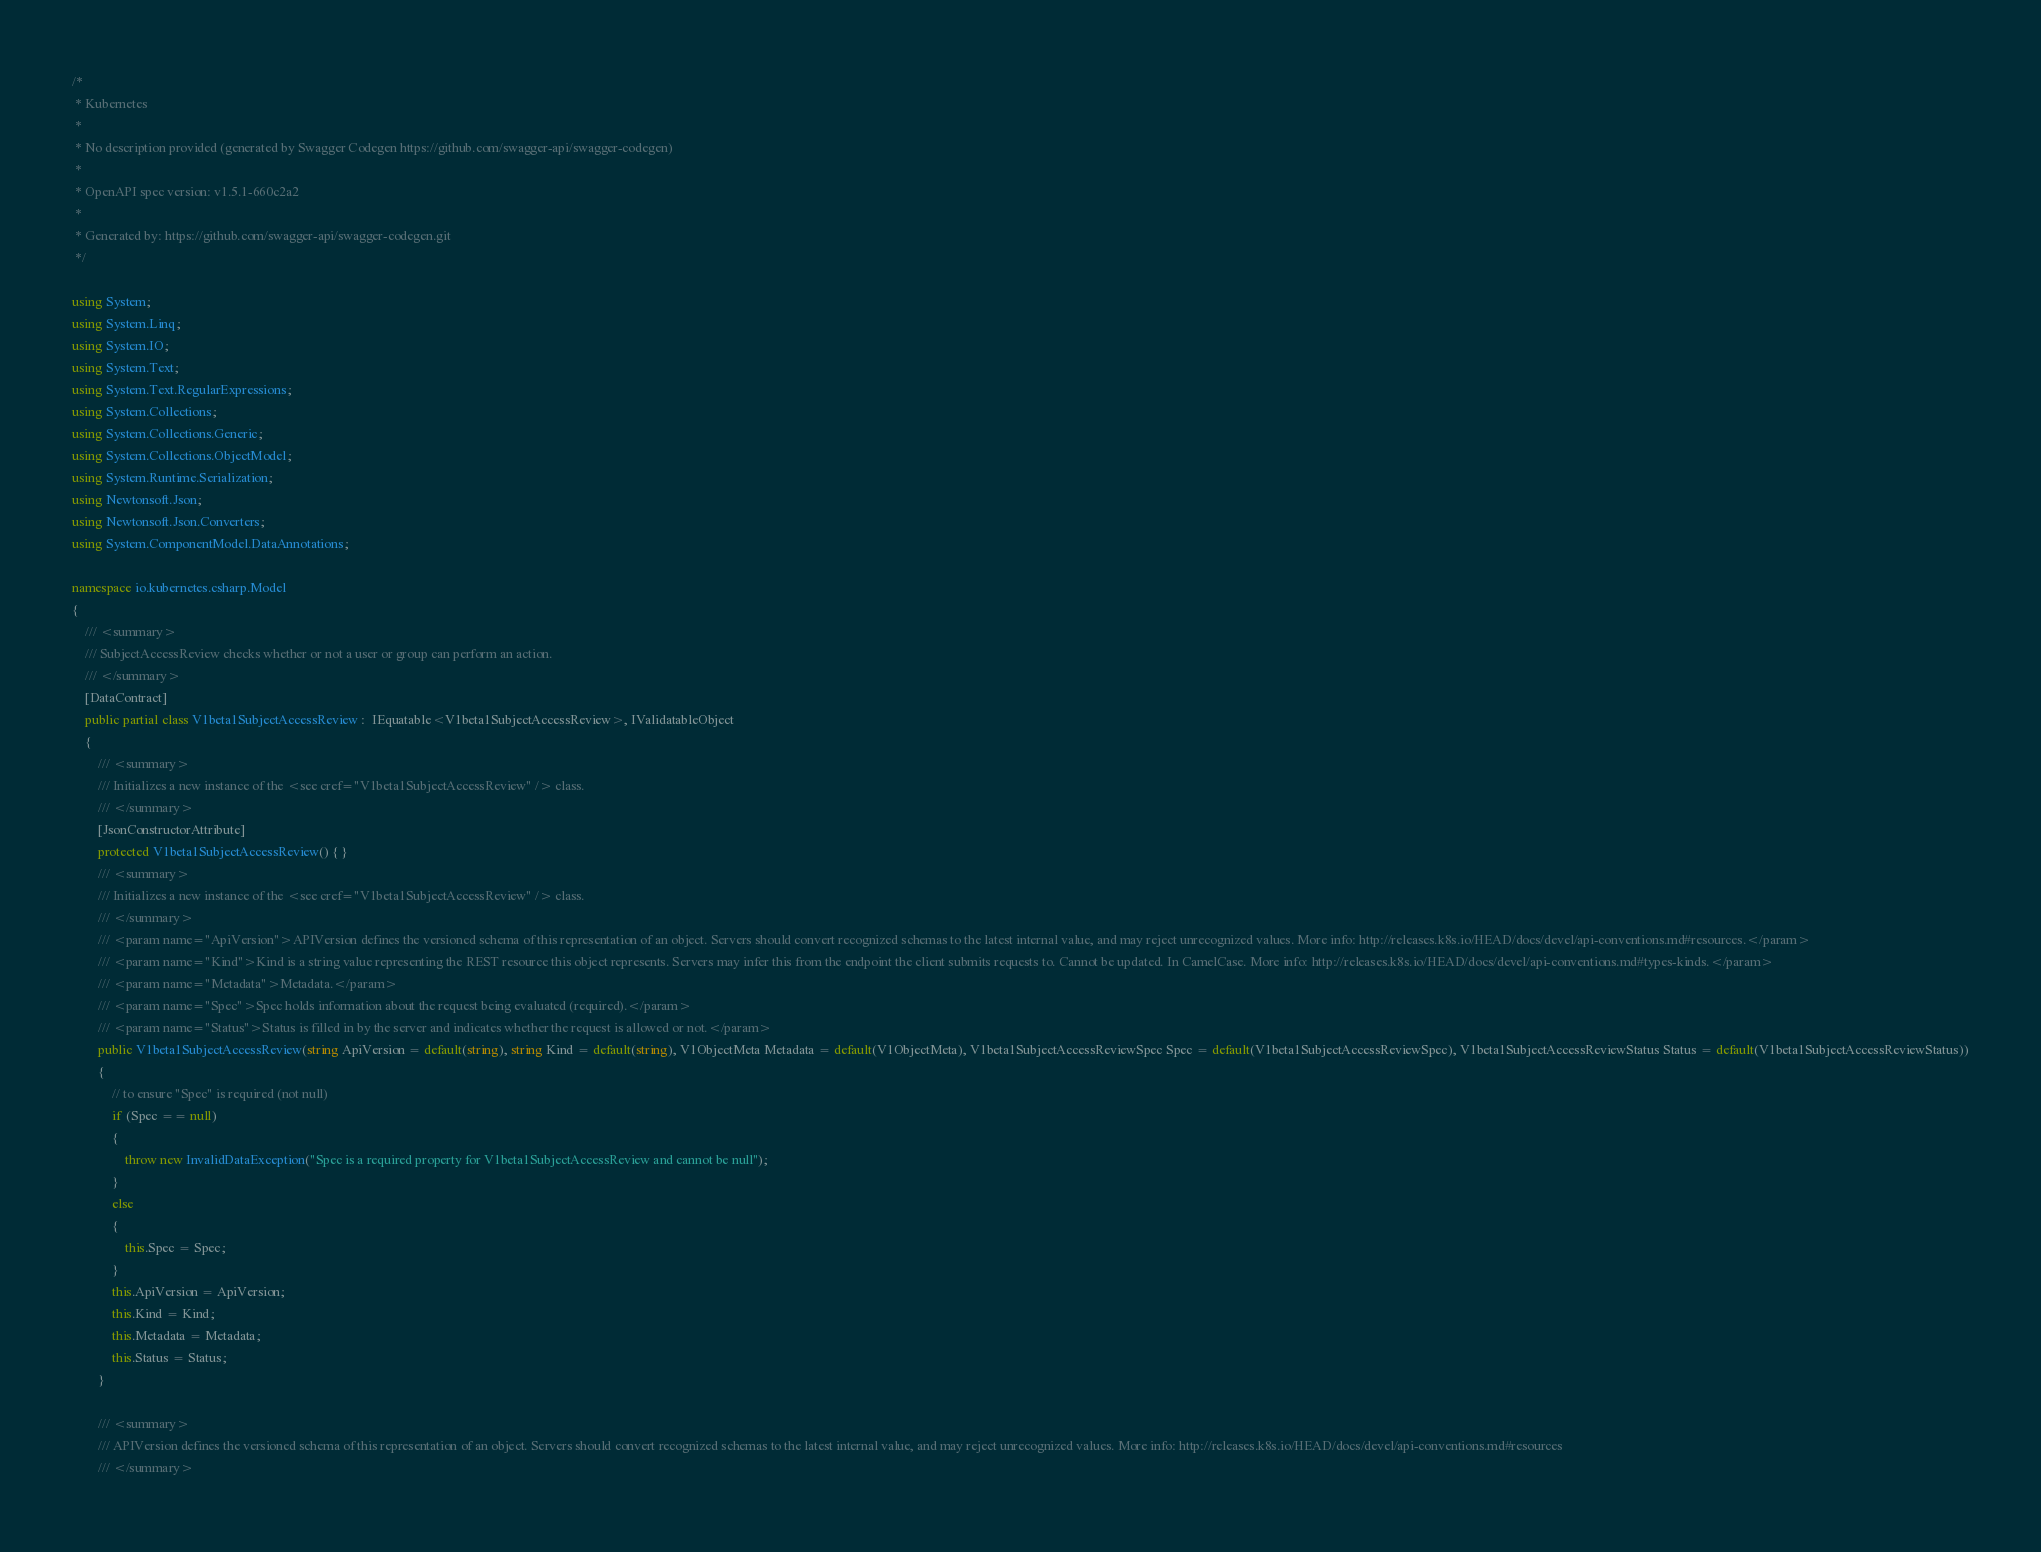<code> <loc_0><loc_0><loc_500><loc_500><_C#_>/* 
 * Kubernetes
 *
 * No description provided (generated by Swagger Codegen https://github.com/swagger-api/swagger-codegen)
 *
 * OpenAPI spec version: v1.5.1-660c2a2
 * 
 * Generated by: https://github.com/swagger-api/swagger-codegen.git
 */

using System;
using System.Linq;
using System.IO;
using System.Text;
using System.Text.RegularExpressions;
using System.Collections;
using System.Collections.Generic;
using System.Collections.ObjectModel;
using System.Runtime.Serialization;
using Newtonsoft.Json;
using Newtonsoft.Json.Converters;
using System.ComponentModel.DataAnnotations;

namespace io.kubernetes.csharp.Model
{
    /// <summary>
    /// SubjectAccessReview checks whether or not a user or group can perform an action.
    /// </summary>
    [DataContract]
    public partial class V1beta1SubjectAccessReview :  IEquatable<V1beta1SubjectAccessReview>, IValidatableObject
    {
        /// <summary>
        /// Initializes a new instance of the <see cref="V1beta1SubjectAccessReview" /> class.
        /// </summary>
        [JsonConstructorAttribute]
        protected V1beta1SubjectAccessReview() { }
        /// <summary>
        /// Initializes a new instance of the <see cref="V1beta1SubjectAccessReview" /> class.
        /// </summary>
        /// <param name="ApiVersion">APIVersion defines the versioned schema of this representation of an object. Servers should convert recognized schemas to the latest internal value, and may reject unrecognized values. More info: http://releases.k8s.io/HEAD/docs/devel/api-conventions.md#resources.</param>
        /// <param name="Kind">Kind is a string value representing the REST resource this object represents. Servers may infer this from the endpoint the client submits requests to. Cannot be updated. In CamelCase. More info: http://releases.k8s.io/HEAD/docs/devel/api-conventions.md#types-kinds.</param>
        /// <param name="Metadata">Metadata.</param>
        /// <param name="Spec">Spec holds information about the request being evaluated (required).</param>
        /// <param name="Status">Status is filled in by the server and indicates whether the request is allowed or not.</param>
        public V1beta1SubjectAccessReview(string ApiVersion = default(string), string Kind = default(string), V1ObjectMeta Metadata = default(V1ObjectMeta), V1beta1SubjectAccessReviewSpec Spec = default(V1beta1SubjectAccessReviewSpec), V1beta1SubjectAccessReviewStatus Status = default(V1beta1SubjectAccessReviewStatus))
        {
            // to ensure "Spec" is required (not null)
            if (Spec == null)
            {
                throw new InvalidDataException("Spec is a required property for V1beta1SubjectAccessReview and cannot be null");
            }
            else
            {
                this.Spec = Spec;
            }
            this.ApiVersion = ApiVersion;
            this.Kind = Kind;
            this.Metadata = Metadata;
            this.Status = Status;
        }
        
        /// <summary>
        /// APIVersion defines the versioned schema of this representation of an object. Servers should convert recognized schemas to the latest internal value, and may reject unrecognized values. More info: http://releases.k8s.io/HEAD/docs/devel/api-conventions.md#resources
        /// </summary></code> 